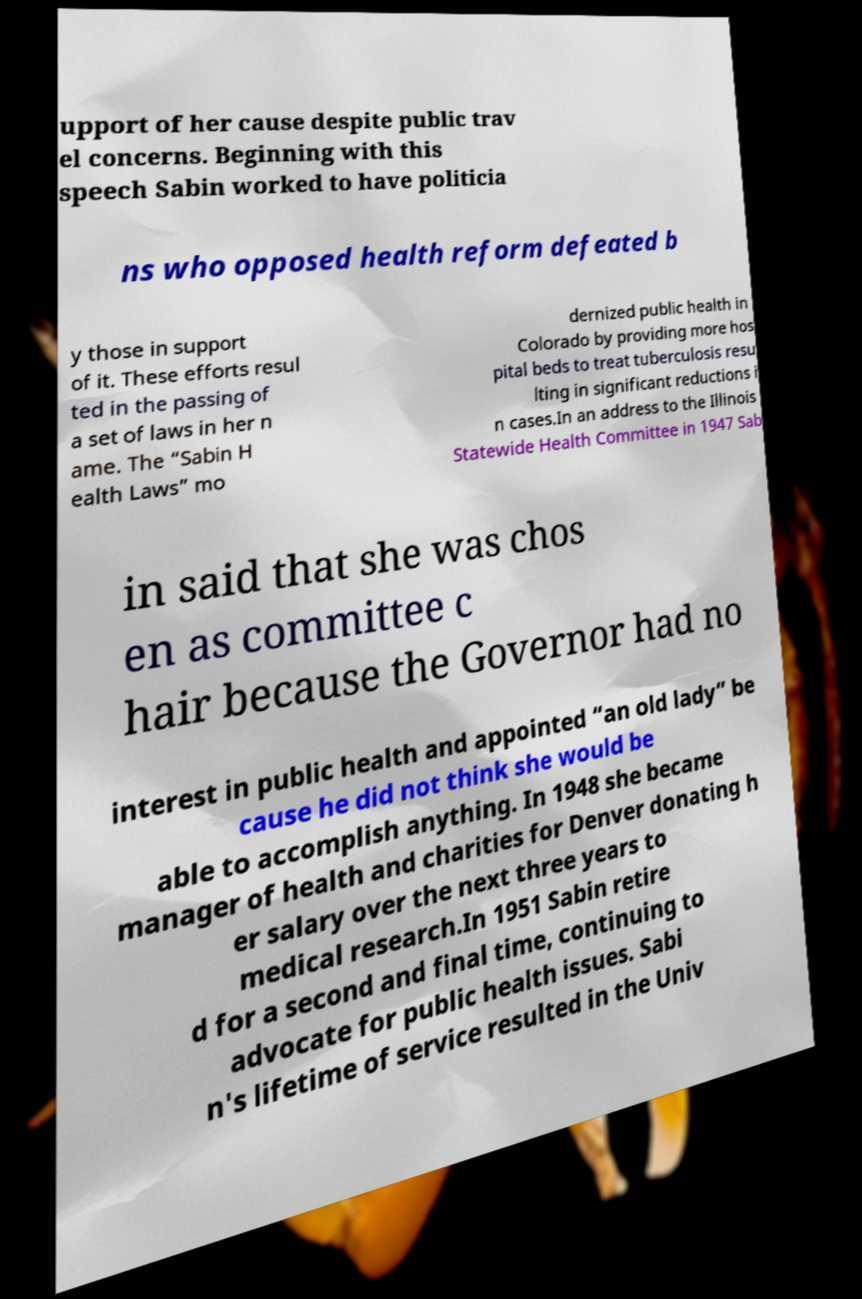Please identify and transcribe the text found in this image. upport of her cause despite public trav el concerns. Beginning with this speech Sabin worked to have politicia ns who opposed health reform defeated b y those in support of it. These efforts resul ted in the passing of a set of laws in her n ame. The “Sabin H ealth Laws” mo dernized public health in Colorado by providing more hos pital beds to treat tuberculosis resu lting in significant reductions i n cases.In an address to the Illinois Statewide Health Committee in 1947 Sab in said that she was chos en as committee c hair because the Governor had no interest in public health and appointed “an old lady” be cause he did not think she would be able to accomplish anything. In 1948 she became manager of health and charities for Denver donating h er salary over the next three years to medical research.In 1951 Sabin retire d for a second and final time, continuing to advocate for public health issues. Sabi n's lifetime of service resulted in the Univ 